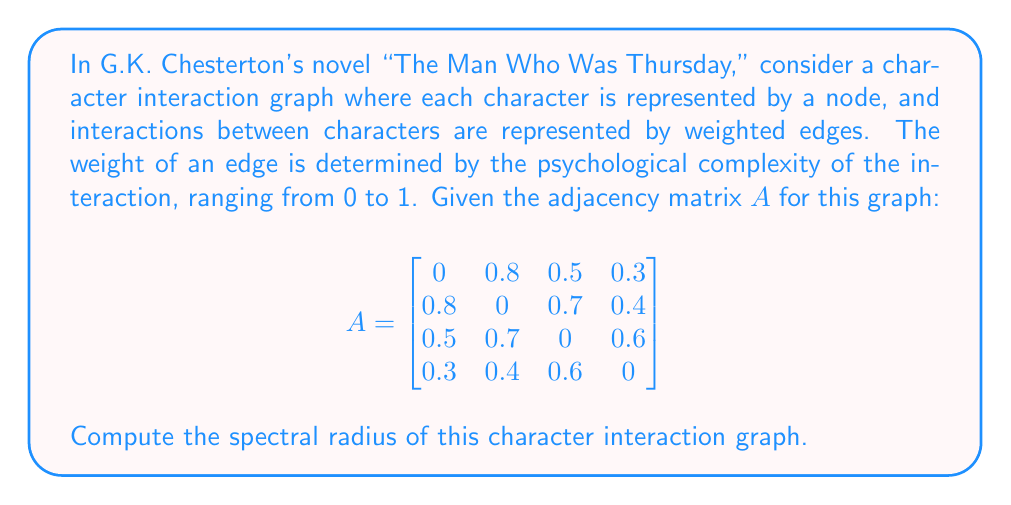Teach me how to tackle this problem. To find the spectral radius of the character interaction graph, we need to follow these steps:

1) The spectral radius is defined as the largest absolute eigenvalue of the adjacency matrix A.

2) To find the eigenvalues, we need to solve the characteristic equation:
   
   $$det(A - \lambda I) = 0$$

   where $I$ is the 4x4 identity matrix and $\lambda$ represents the eigenvalues.

3) Expanding this determinant gives us the characteristic polynomial:

   $$\lambda^4 - 1.54\lambda^2 - 0.5776 = 0$$

4) This is a quadratic equation in $\lambda^2$. Let $u = \lambda^2$, then we have:

   $$u^2 - 1.54u - 0.5776 = 0$$

5) Using the quadratic formula, we can solve for u:

   $$u = \frac{1.54 \pm \sqrt{1.54^2 + 4(0.5776)}}{2}$$

6) This gives us:
   
   $$u_1 = 1.7889 \text{ and } u_2 = -0.2489$$

7) Since we're looking for $\lambda$, and $\lambda^2 = u$, we take the square root:

   $$\lambda = \pm\sqrt{1.7889} \text{ and } \lambda = \pm\sqrt{0.2489}$$

8) The spectral radius is the largest absolute value among these:

   $$\rho(A) = \sqrt{1.7889} \approx 1.3375$$
Answer: $1.3375$ 